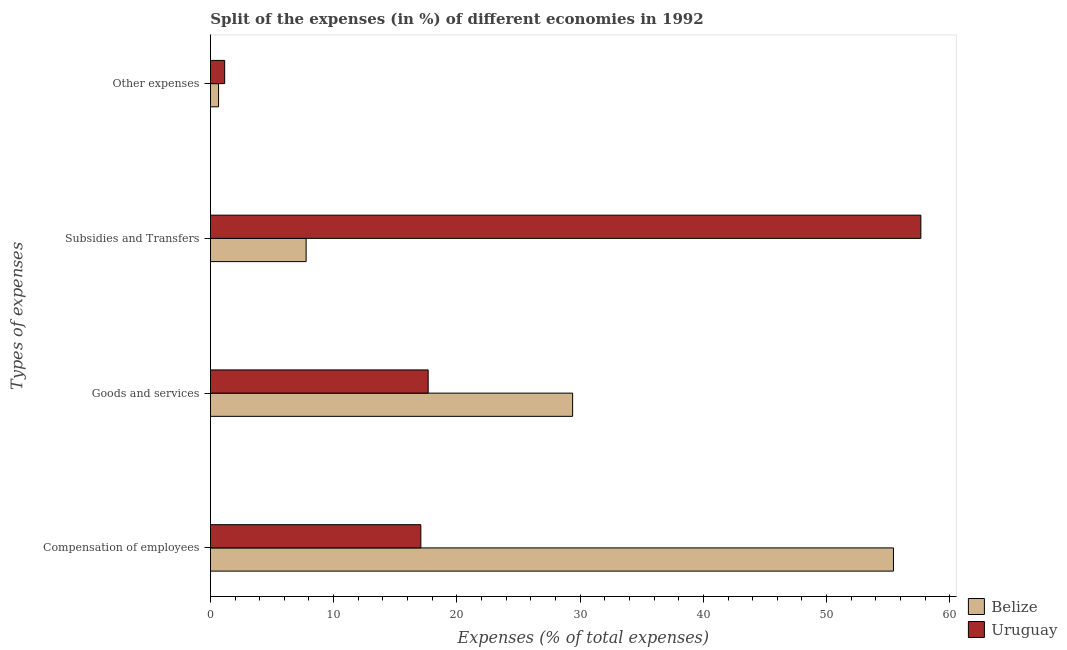Are the number of bars per tick equal to the number of legend labels?
Your response must be concise. Yes. Are the number of bars on each tick of the Y-axis equal?
Give a very brief answer. Yes. How many bars are there on the 3rd tick from the bottom?
Offer a very short reply. 2. What is the label of the 4th group of bars from the top?
Provide a short and direct response. Compensation of employees. What is the percentage of amount spent on goods and services in Uruguay?
Offer a terse response. 17.67. Across all countries, what is the maximum percentage of amount spent on goods and services?
Ensure brevity in your answer.  29.39. Across all countries, what is the minimum percentage of amount spent on other expenses?
Offer a very short reply. 0.66. In which country was the percentage of amount spent on subsidies maximum?
Your answer should be very brief. Uruguay. In which country was the percentage of amount spent on subsidies minimum?
Ensure brevity in your answer.  Belize. What is the total percentage of amount spent on goods and services in the graph?
Your answer should be compact. 47.06. What is the difference between the percentage of amount spent on goods and services in Uruguay and that in Belize?
Your answer should be very brief. -11.72. What is the difference between the percentage of amount spent on compensation of employees in Belize and the percentage of amount spent on goods and services in Uruguay?
Your answer should be very brief. 37.75. What is the average percentage of amount spent on subsidies per country?
Provide a short and direct response. 32.71. What is the difference between the percentage of amount spent on other expenses and percentage of amount spent on goods and services in Uruguay?
Provide a succinct answer. -16.51. In how many countries, is the percentage of amount spent on goods and services greater than 40 %?
Ensure brevity in your answer.  0. What is the ratio of the percentage of amount spent on goods and services in Uruguay to that in Belize?
Your answer should be very brief. 0.6. What is the difference between the highest and the second highest percentage of amount spent on subsidies?
Make the answer very short. 49.88. What is the difference between the highest and the lowest percentage of amount spent on goods and services?
Your answer should be compact. 11.72. In how many countries, is the percentage of amount spent on compensation of employees greater than the average percentage of amount spent on compensation of employees taken over all countries?
Offer a terse response. 1. What does the 1st bar from the top in Goods and services represents?
Your answer should be very brief. Uruguay. What does the 1st bar from the bottom in Other expenses represents?
Your answer should be very brief. Belize. Is it the case that in every country, the sum of the percentage of amount spent on compensation of employees and percentage of amount spent on goods and services is greater than the percentage of amount spent on subsidies?
Offer a terse response. No. How are the legend labels stacked?
Your response must be concise. Vertical. What is the title of the graph?
Ensure brevity in your answer.  Split of the expenses (in %) of different economies in 1992. Does "Low & middle income" appear as one of the legend labels in the graph?
Give a very brief answer. No. What is the label or title of the X-axis?
Your answer should be very brief. Expenses (% of total expenses). What is the label or title of the Y-axis?
Your answer should be very brief. Types of expenses. What is the Expenses (% of total expenses) in Belize in Compensation of employees?
Offer a very short reply. 55.42. What is the Expenses (% of total expenses) in Uruguay in Compensation of employees?
Your answer should be compact. 17.08. What is the Expenses (% of total expenses) of Belize in Goods and services?
Keep it short and to the point. 29.39. What is the Expenses (% of total expenses) of Uruguay in Goods and services?
Your response must be concise. 17.67. What is the Expenses (% of total expenses) of Belize in Subsidies and Transfers?
Make the answer very short. 7.77. What is the Expenses (% of total expenses) in Uruguay in Subsidies and Transfers?
Make the answer very short. 57.65. What is the Expenses (% of total expenses) in Belize in Other expenses?
Your answer should be compact. 0.66. What is the Expenses (% of total expenses) of Uruguay in Other expenses?
Make the answer very short. 1.16. Across all Types of expenses, what is the maximum Expenses (% of total expenses) of Belize?
Keep it short and to the point. 55.42. Across all Types of expenses, what is the maximum Expenses (% of total expenses) of Uruguay?
Provide a succinct answer. 57.65. Across all Types of expenses, what is the minimum Expenses (% of total expenses) of Belize?
Provide a short and direct response. 0.66. Across all Types of expenses, what is the minimum Expenses (% of total expenses) of Uruguay?
Provide a succinct answer. 1.16. What is the total Expenses (% of total expenses) in Belize in the graph?
Give a very brief answer. 93.24. What is the total Expenses (% of total expenses) in Uruguay in the graph?
Provide a succinct answer. 93.55. What is the difference between the Expenses (% of total expenses) in Belize in Compensation of employees and that in Goods and services?
Offer a terse response. 26.03. What is the difference between the Expenses (% of total expenses) in Uruguay in Compensation of employees and that in Goods and services?
Make the answer very short. -0.59. What is the difference between the Expenses (% of total expenses) in Belize in Compensation of employees and that in Subsidies and Transfers?
Your answer should be very brief. 47.65. What is the difference between the Expenses (% of total expenses) in Uruguay in Compensation of employees and that in Subsidies and Transfers?
Offer a very short reply. -40.57. What is the difference between the Expenses (% of total expenses) of Belize in Compensation of employees and that in Other expenses?
Keep it short and to the point. 54.76. What is the difference between the Expenses (% of total expenses) of Uruguay in Compensation of employees and that in Other expenses?
Give a very brief answer. 15.92. What is the difference between the Expenses (% of total expenses) of Belize in Goods and services and that in Subsidies and Transfers?
Give a very brief answer. 21.62. What is the difference between the Expenses (% of total expenses) in Uruguay in Goods and services and that in Subsidies and Transfers?
Ensure brevity in your answer.  -39.98. What is the difference between the Expenses (% of total expenses) in Belize in Goods and services and that in Other expenses?
Your answer should be compact. 28.73. What is the difference between the Expenses (% of total expenses) in Uruguay in Goods and services and that in Other expenses?
Provide a short and direct response. 16.51. What is the difference between the Expenses (% of total expenses) of Belize in Subsidies and Transfers and that in Other expenses?
Provide a succinct answer. 7.1. What is the difference between the Expenses (% of total expenses) in Uruguay in Subsidies and Transfers and that in Other expenses?
Make the answer very short. 56.49. What is the difference between the Expenses (% of total expenses) in Belize in Compensation of employees and the Expenses (% of total expenses) in Uruguay in Goods and services?
Keep it short and to the point. 37.75. What is the difference between the Expenses (% of total expenses) in Belize in Compensation of employees and the Expenses (% of total expenses) in Uruguay in Subsidies and Transfers?
Make the answer very short. -2.22. What is the difference between the Expenses (% of total expenses) of Belize in Compensation of employees and the Expenses (% of total expenses) of Uruguay in Other expenses?
Make the answer very short. 54.26. What is the difference between the Expenses (% of total expenses) in Belize in Goods and services and the Expenses (% of total expenses) in Uruguay in Subsidies and Transfers?
Make the answer very short. -28.25. What is the difference between the Expenses (% of total expenses) of Belize in Goods and services and the Expenses (% of total expenses) of Uruguay in Other expenses?
Provide a short and direct response. 28.23. What is the difference between the Expenses (% of total expenses) in Belize in Subsidies and Transfers and the Expenses (% of total expenses) in Uruguay in Other expenses?
Give a very brief answer. 6.61. What is the average Expenses (% of total expenses) of Belize per Types of expenses?
Provide a succinct answer. 23.31. What is the average Expenses (% of total expenses) of Uruguay per Types of expenses?
Keep it short and to the point. 23.39. What is the difference between the Expenses (% of total expenses) of Belize and Expenses (% of total expenses) of Uruguay in Compensation of employees?
Keep it short and to the point. 38.35. What is the difference between the Expenses (% of total expenses) in Belize and Expenses (% of total expenses) in Uruguay in Goods and services?
Offer a very short reply. 11.72. What is the difference between the Expenses (% of total expenses) of Belize and Expenses (% of total expenses) of Uruguay in Subsidies and Transfers?
Your response must be concise. -49.88. What is the difference between the Expenses (% of total expenses) in Belize and Expenses (% of total expenses) in Uruguay in Other expenses?
Your answer should be compact. -0.5. What is the ratio of the Expenses (% of total expenses) in Belize in Compensation of employees to that in Goods and services?
Offer a terse response. 1.89. What is the ratio of the Expenses (% of total expenses) of Uruguay in Compensation of employees to that in Goods and services?
Offer a very short reply. 0.97. What is the ratio of the Expenses (% of total expenses) of Belize in Compensation of employees to that in Subsidies and Transfers?
Offer a very short reply. 7.13. What is the ratio of the Expenses (% of total expenses) in Uruguay in Compensation of employees to that in Subsidies and Transfers?
Keep it short and to the point. 0.3. What is the ratio of the Expenses (% of total expenses) of Belize in Compensation of employees to that in Other expenses?
Offer a very short reply. 83.49. What is the ratio of the Expenses (% of total expenses) of Uruguay in Compensation of employees to that in Other expenses?
Your response must be concise. 14.73. What is the ratio of the Expenses (% of total expenses) in Belize in Goods and services to that in Subsidies and Transfers?
Keep it short and to the point. 3.78. What is the ratio of the Expenses (% of total expenses) of Uruguay in Goods and services to that in Subsidies and Transfers?
Your answer should be very brief. 0.31. What is the ratio of the Expenses (% of total expenses) in Belize in Goods and services to that in Other expenses?
Give a very brief answer. 44.28. What is the ratio of the Expenses (% of total expenses) in Uruguay in Goods and services to that in Other expenses?
Offer a very short reply. 15.25. What is the ratio of the Expenses (% of total expenses) in Belize in Subsidies and Transfers to that in Other expenses?
Make the answer very short. 11.7. What is the ratio of the Expenses (% of total expenses) in Uruguay in Subsidies and Transfers to that in Other expenses?
Your answer should be compact. 49.74. What is the difference between the highest and the second highest Expenses (% of total expenses) of Belize?
Provide a succinct answer. 26.03. What is the difference between the highest and the second highest Expenses (% of total expenses) in Uruguay?
Your response must be concise. 39.98. What is the difference between the highest and the lowest Expenses (% of total expenses) of Belize?
Ensure brevity in your answer.  54.76. What is the difference between the highest and the lowest Expenses (% of total expenses) in Uruguay?
Keep it short and to the point. 56.49. 